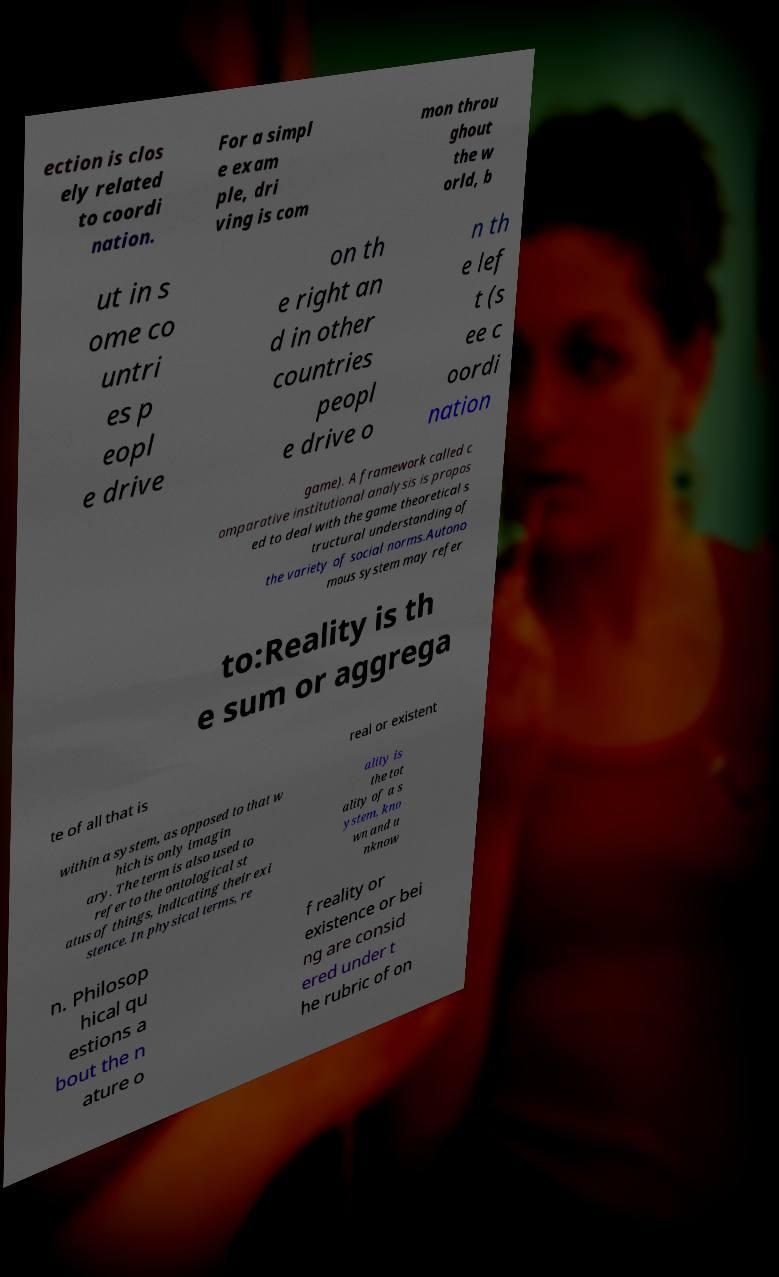I need the written content from this picture converted into text. Can you do that? ection is clos ely related to coordi nation. For a simpl e exam ple, dri ving is com mon throu ghout the w orld, b ut in s ome co untri es p eopl e drive on th e right an d in other countries peopl e drive o n th e lef t (s ee c oordi nation game). A framework called c omparative institutional analysis is propos ed to deal with the game theoretical s tructural understanding of the variety of social norms.Autono mous system may refer to:Reality is th e sum or aggrega te of all that is real or existent within a system, as opposed to that w hich is only imagin ary. The term is also used to refer to the ontological st atus of things, indicating their exi stence. In physical terms, re ality is the tot ality of a s ystem, kno wn and u nknow n. Philosop hical qu estions a bout the n ature o f reality or existence or bei ng are consid ered under t he rubric of on 